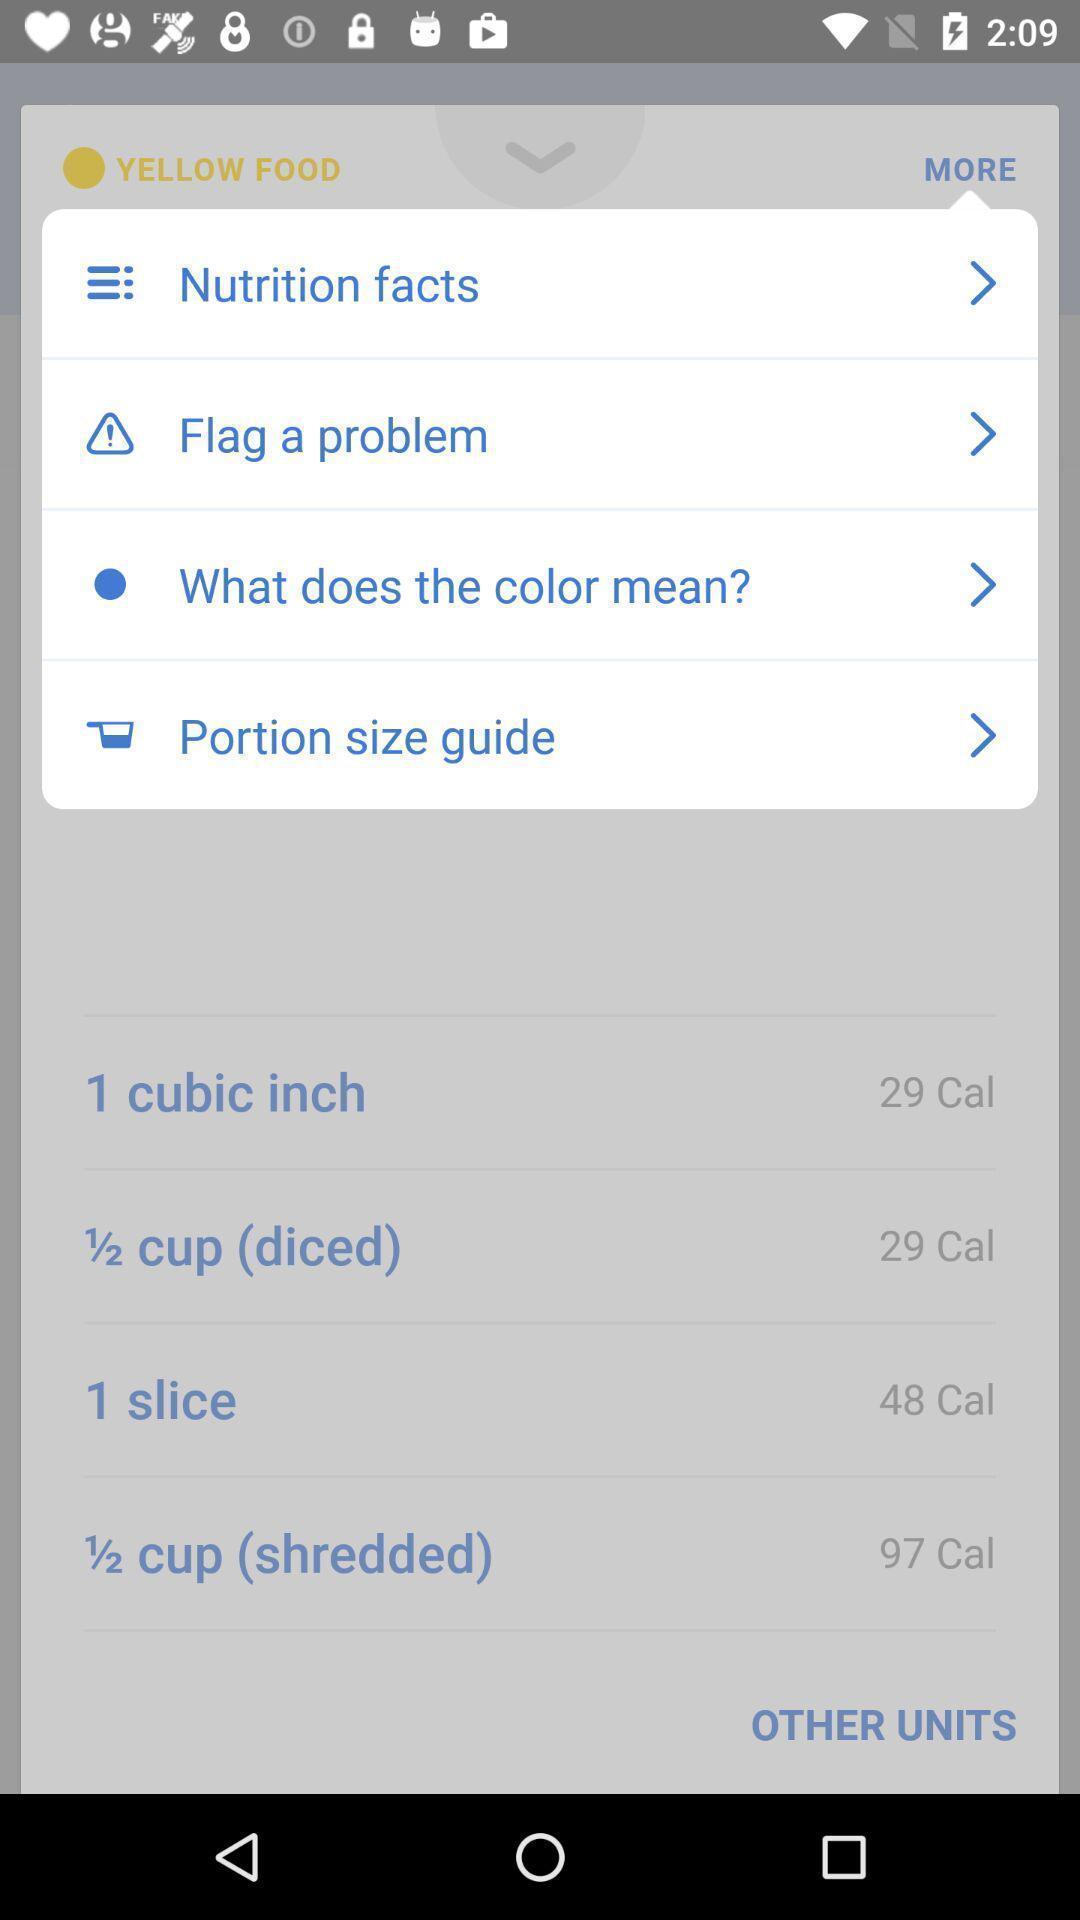Summarize the main components in this picture. Screen displaying list of more options in app. 